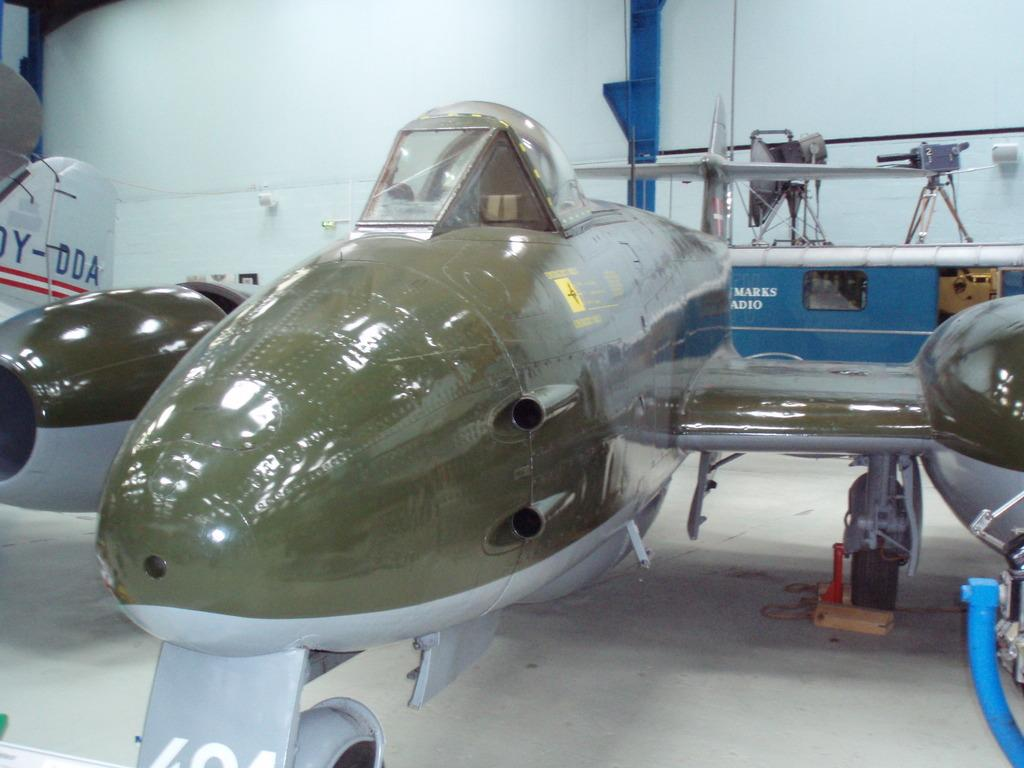What is the main subject of the image? The main subject of the image is a flight. Where is the flight located? The flight is inside a compartment. What can be seen in the background of the image? There is a wall in the background of the image. What type of fowl can be seen smiling in the image? There is no fowl or smiling expression present in the image. What record is being broken by the flight in the image? There is no mention of a record being broken in the image. 